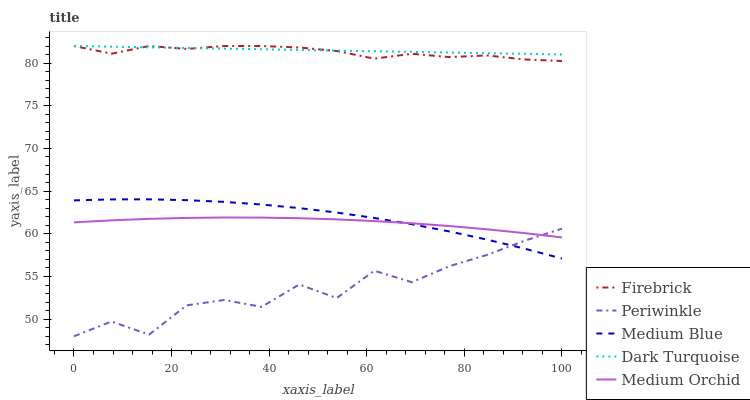Does Firebrick have the minimum area under the curve?
Answer yes or no. No. Does Firebrick have the maximum area under the curve?
Answer yes or no. No. Is Firebrick the smoothest?
Answer yes or no. No. Is Firebrick the roughest?
Answer yes or no. No. Does Firebrick have the lowest value?
Answer yes or no. No. Does Medium Orchid have the highest value?
Answer yes or no. No. Is Medium Blue less than Firebrick?
Answer yes or no. Yes. Is Firebrick greater than Periwinkle?
Answer yes or no. Yes. Does Medium Blue intersect Firebrick?
Answer yes or no. No. 